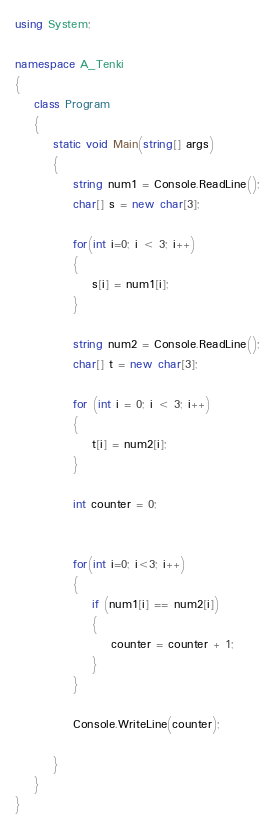Convert code to text. <code><loc_0><loc_0><loc_500><loc_500><_C#_>using System;

namespace A_Tenki
{
    class Program
    {
        static void Main(string[] args)
        {
            string num1 = Console.ReadLine();
            char[] s = new char[3];
            
            for(int i=0; i < 3; i++)
            {
                s[i] = num1[i];
            }

            string num2 = Console.ReadLine();
            char[] t = new char[3];

            for (int i = 0; i < 3; i++)
            {
                t[i] = num2[i];
            }

            int counter = 0;


            for(int i=0; i<3; i++)
            {
                if (num1[i] == num2[i])
                {
                    counter = counter + 1;
                }
            }

            Console.WriteLine(counter);

        }
    }
}
</code> 